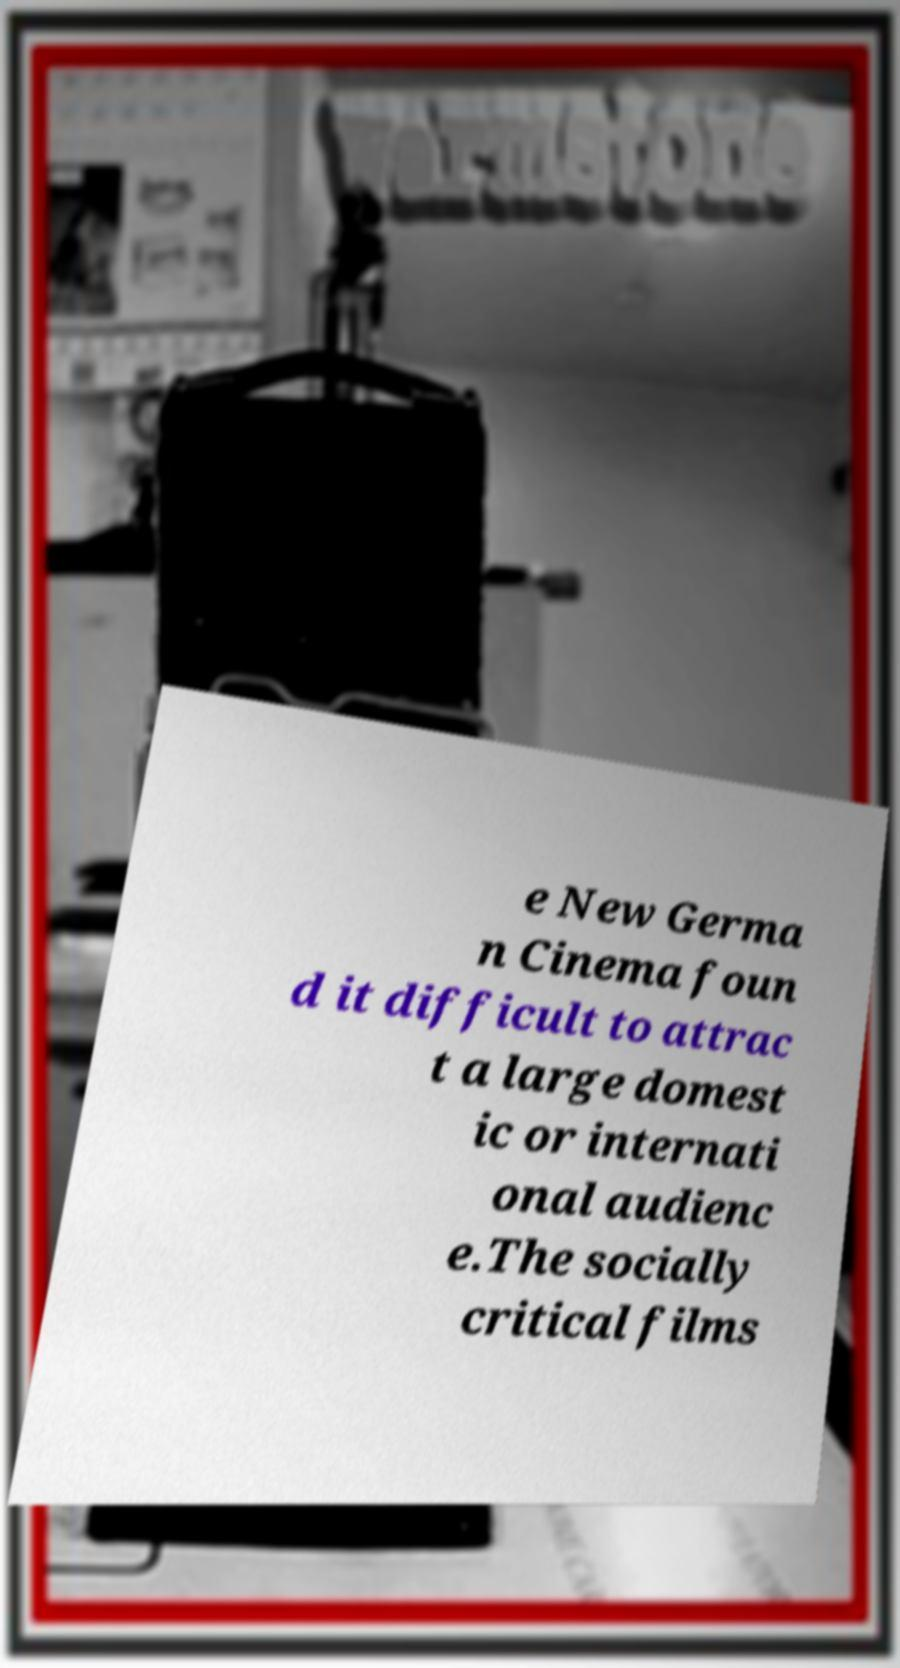Could you extract and type out the text from this image? e New Germa n Cinema foun d it difficult to attrac t a large domest ic or internati onal audienc e.The socially critical films 